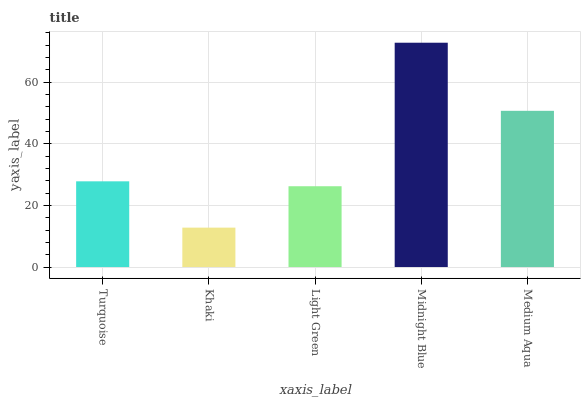Is Khaki the minimum?
Answer yes or no. Yes. Is Midnight Blue the maximum?
Answer yes or no. Yes. Is Light Green the minimum?
Answer yes or no. No. Is Light Green the maximum?
Answer yes or no. No. Is Light Green greater than Khaki?
Answer yes or no. Yes. Is Khaki less than Light Green?
Answer yes or no. Yes. Is Khaki greater than Light Green?
Answer yes or no. No. Is Light Green less than Khaki?
Answer yes or no. No. Is Turquoise the high median?
Answer yes or no. Yes. Is Turquoise the low median?
Answer yes or no. Yes. Is Midnight Blue the high median?
Answer yes or no. No. Is Light Green the low median?
Answer yes or no. No. 